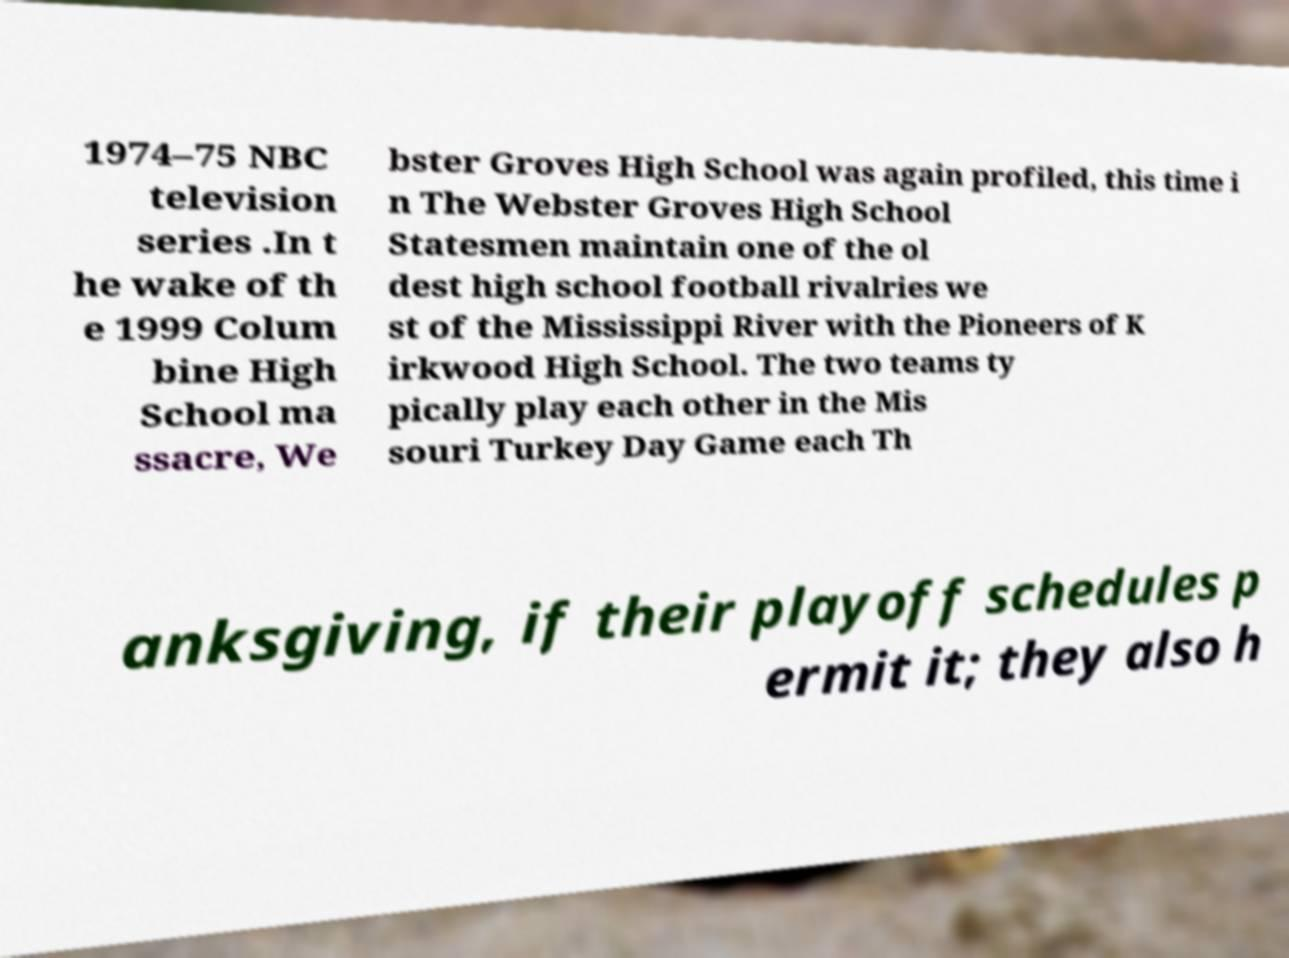Could you extract and type out the text from this image? 1974–75 NBC television series .In t he wake of th e 1999 Colum bine High School ma ssacre, We bster Groves High School was again profiled, this time i n The Webster Groves High School Statesmen maintain one of the ol dest high school football rivalries we st of the Mississippi River with the Pioneers of K irkwood High School. The two teams ty pically play each other in the Mis souri Turkey Day Game each Th anksgiving, if their playoff schedules p ermit it; they also h 